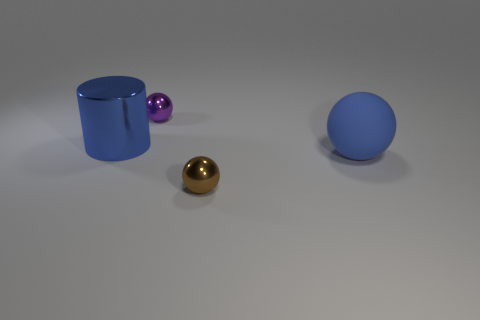How would you describe the lighting and shadows created in this scene? The lighting in the scene appears to be coming from above, casting soft shadows directly beneath the objects. These shadows are quite subtle and suggest a diffuse light source, giving the scene a calm and evenly lit appearance without harsh contrasts. 